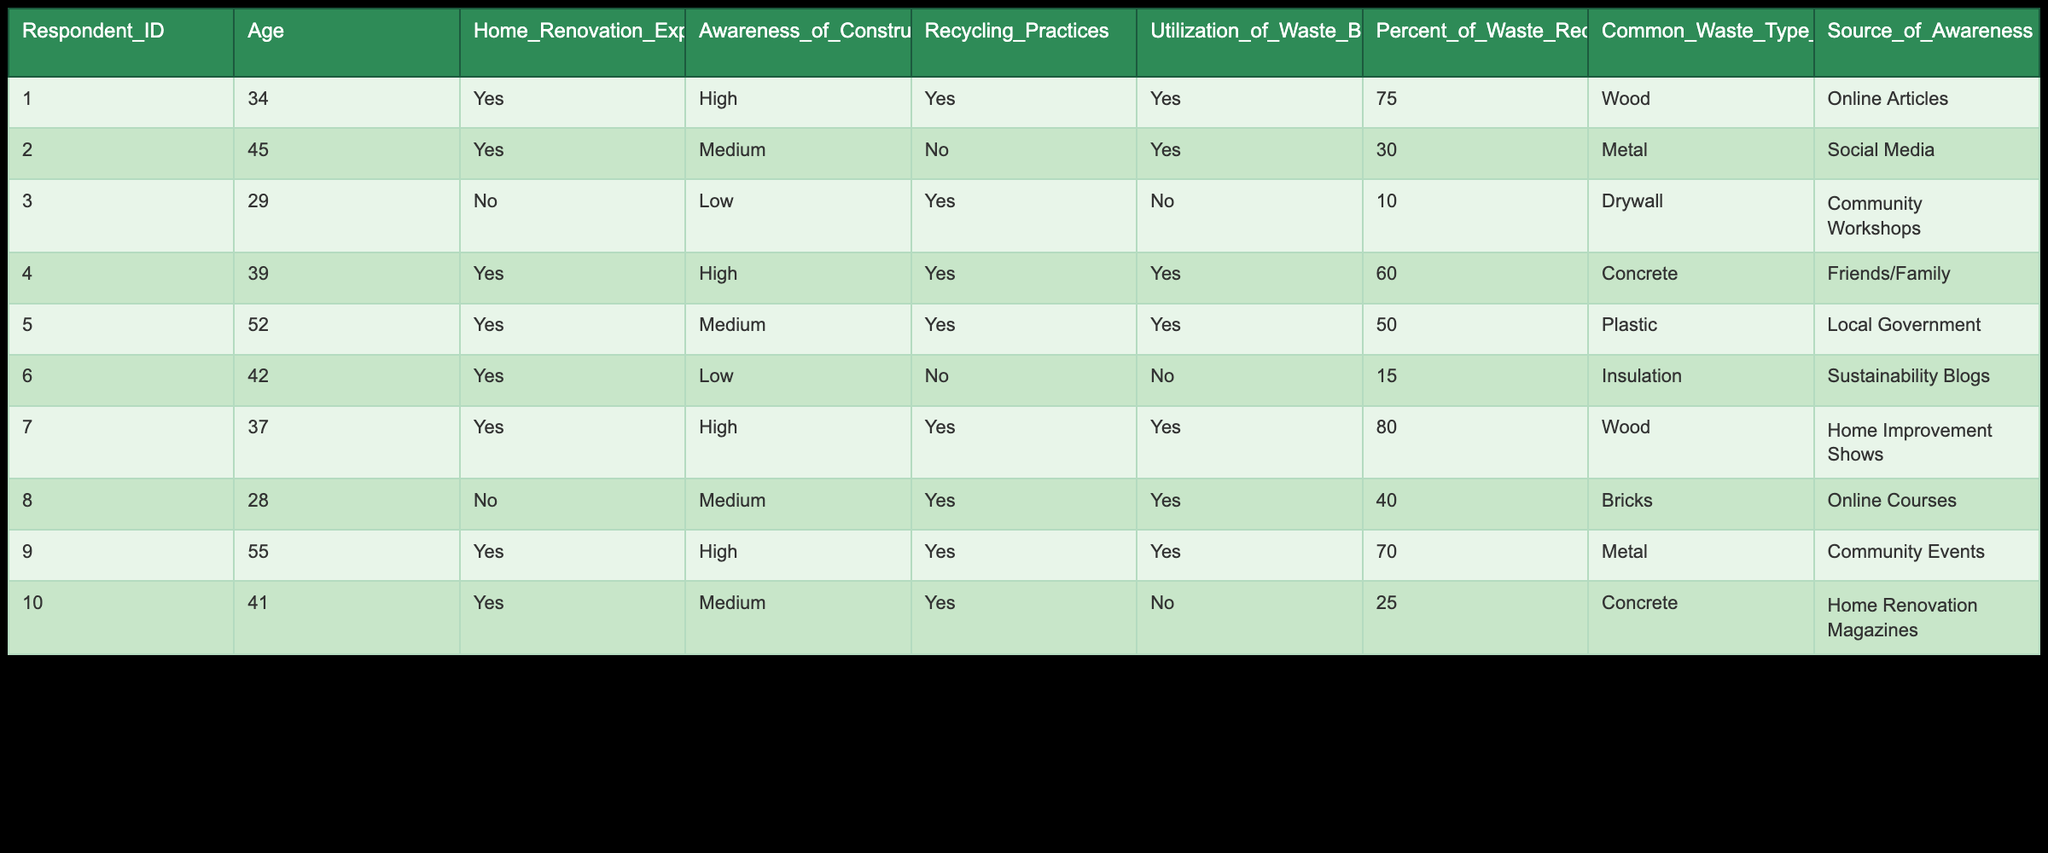What percentage of waste is recycled by the respondent with the highest recycling rate? The respondent with the highest recycling rate is ID 7, who recycles 80% of their waste.
Answer: 80 How many respondents reported a high level of awareness of construction waste management? There are 4 respondents (IDs 1, 4, 7, and 9) who reported a high level of awareness.
Answer: 4 What type of waste is most commonly disposed of by respondents? The most common waste types listed are Wood (IDs 1 and 7), Metal (IDs 2 and 9), and Concrete (IDs 4 and 10), making it equal between Wood and Metal at 2 respondents each.
Answer: Wood and Metal What is the average percentage of waste recycled by all respondents? Add the percentage recycled by each respondent: (75 + 30 + 10 + 60 + 50 + 15 + 80 + 40 + 70 + 25) = 455. There are 10 respondents, so the average is 455 / 10 = 45.5.
Answer: 45.5 Is there any respondent who did not utilize waste bins but recycled some waste? Yes, respondent ID 6 did not utilize waste bins and recycled 15% of their waste.
Answer: Yes What is the average age of respondents who have experience with home renovations? The ages of respondents with renovation experience (IDs 1, 2, 4, 5, 6, 7, 9, 10) are 34, 45, 39, 52, 42, 37, 55, and 41, summing to  34 + 45 + 39 + 52 + 42 + 37 + 55 + 41 =  343. There are 8 respondents, so the average age is 343 / 8 = 42.875, which rounds to 43.
Answer: 43 How many respondents learned about construction waste management from online articles? Respondents ID 1 and 8 reported that they learned from online articles, totaling 2 respondents.
Answer: 2 Which source of awareness had the most respondents? The source "Community Events" had the most respondents, specifically ID 9.
Answer: Community Events What is the difference between the highest and lowest percentage of waste recycled by respondents? The highest recycling rate is 80% (ID 7) and the lowest is 10% (ID 3). The difference is 80 - 10 = 70.
Answer: 70 